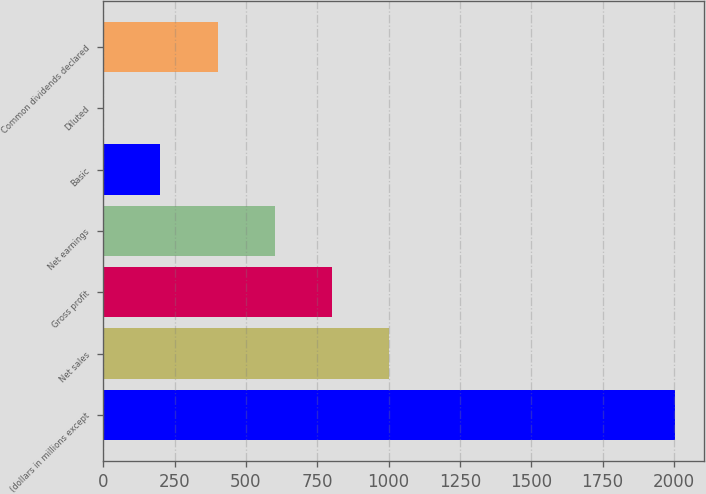Convert chart. <chart><loc_0><loc_0><loc_500><loc_500><bar_chart><fcel>(dollars in millions except<fcel>Net sales<fcel>Gross profit<fcel>Net earnings<fcel>Basic<fcel>Diluted<fcel>Common dividends declared<nl><fcel>2004<fcel>1002.06<fcel>801.68<fcel>601.3<fcel>200.53<fcel>0.15<fcel>400.91<nl></chart> 